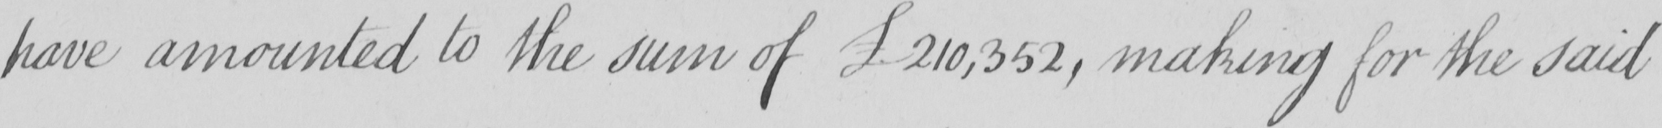What text is written in this handwritten line? have amounted to the sum of £210,352 , making for the said 